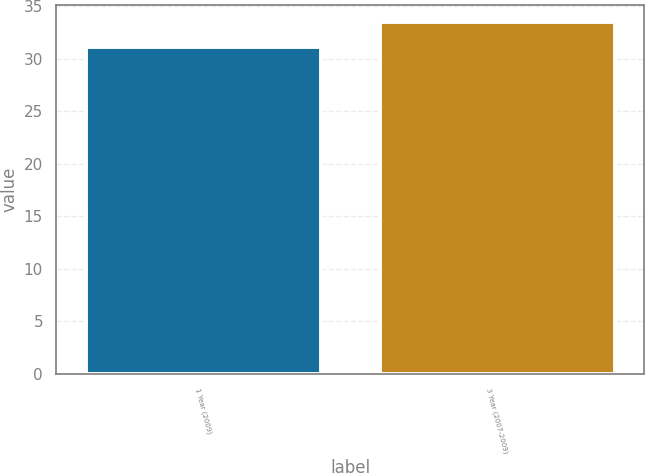Convert chart to OTSL. <chart><loc_0><loc_0><loc_500><loc_500><bar_chart><fcel>1 Year (2009)<fcel>3 Year (2007-2009)<nl><fcel>31.1<fcel>33.5<nl></chart> 